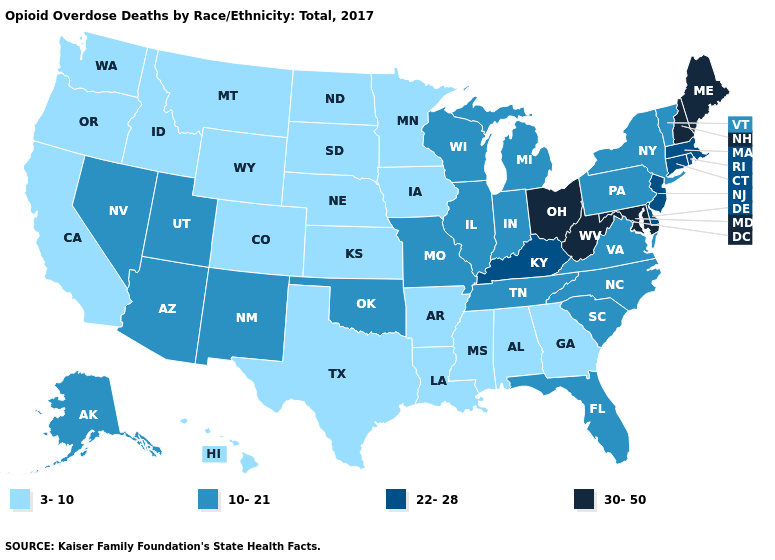Does Maine have the highest value in the Northeast?
Write a very short answer. Yes. Which states have the lowest value in the USA?
Short answer required. Alabama, Arkansas, California, Colorado, Georgia, Hawaii, Idaho, Iowa, Kansas, Louisiana, Minnesota, Mississippi, Montana, Nebraska, North Dakota, Oregon, South Dakota, Texas, Washington, Wyoming. Does the first symbol in the legend represent the smallest category?
Short answer required. Yes. Does Ohio have the highest value in the MidWest?
Be succinct. Yes. Does Nebraska have the same value as Hawaii?
Short answer required. Yes. Name the states that have a value in the range 30-50?
Be succinct. Maine, Maryland, New Hampshire, Ohio, West Virginia. What is the value of Montana?
Quick response, please. 3-10. Name the states that have a value in the range 30-50?
Answer briefly. Maine, Maryland, New Hampshire, Ohio, West Virginia. What is the lowest value in the USA?
Keep it brief. 3-10. What is the value of Texas?
Short answer required. 3-10. What is the value of Utah?
Give a very brief answer. 10-21. Which states have the lowest value in the MidWest?
Short answer required. Iowa, Kansas, Minnesota, Nebraska, North Dakota, South Dakota. What is the lowest value in the USA?
Quick response, please. 3-10. How many symbols are there in the legend?
Concise answer only. 4. Name the states that have a value in the range 3-10?
Concise answer only. Alabama, Arkansas, California, Colorado, Georgia, Hawaii, Idaho, Iowa, Kansas, Louisiana, Minnesota, Mississippi, Montana, Nebraska, North Dakota, Oregon, South Dakota, Texas, Washington, Wyoming. 